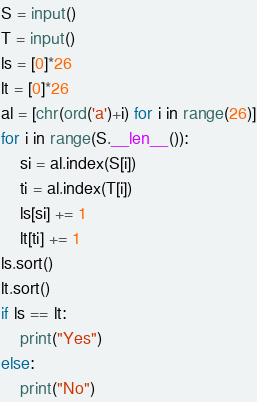<code> <loc_0><loc_0><loc_500><loc_500><_Python_>S = input()
T = input()
ls = [0]*26
lt = [0]*26
al = [chr(ord('a')+i) for i in range(26)]
for i in range(S.__len__()):
    si = al.index(S[i])
    ti = al.index(T[i])
    ls[si] += 1
    lt[ti] += 1
ls.sort()
lt.sort()
if ls == lt:
    print("Yes")
else:
    print("No")
</code> 